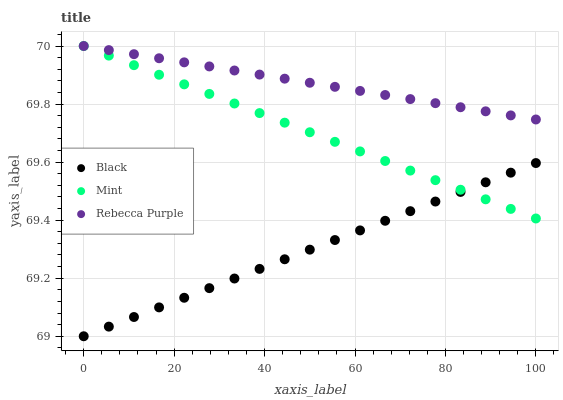Does Black have the minimum area under the curve?
Answer yes or no. Yes. Does Rebecca Purple have the maximum area under the curve?
Answer yes or no. Yes. Does Rebecca Purple have the minimum area under the curve?
Answer yes or no. No. Does Black have the maximum area under the curve?
Answer yes or no. No. Is Mint the smoothest?
Answer yes or no. Yes. Is Rebecca Purple the roughest?
Answer yes or no. Yes. Is Black the smoothest?
Answer yes or no. No. Is Black the roughest?
Answer yes or no. No. Does Black have the lowest value?
Answer yes or no. Yes. Does Rebecca Purple have the lowest value?
Answer yes or no. No. Does Rebecca Purple have the highest value?
Answer yes or no. Yes. Does Black have the highest value?
Answer yes or no. No. Is Black less than Rebecca Purple?
Answer yes or no. Yes. Is Rebecca Purple greater than Black?
Answer yes or no. Yes. Does Mint intersect Rebecca Purple?
Answer yes or no. Yes. Is Mint less than Rebecca Purple?
Answer yes or no. No. Is Mint greater than Rebecca Purple?
Answer yes or no. No. Does Black intersect Rebecca Purple?
Answer yes or no. No. 